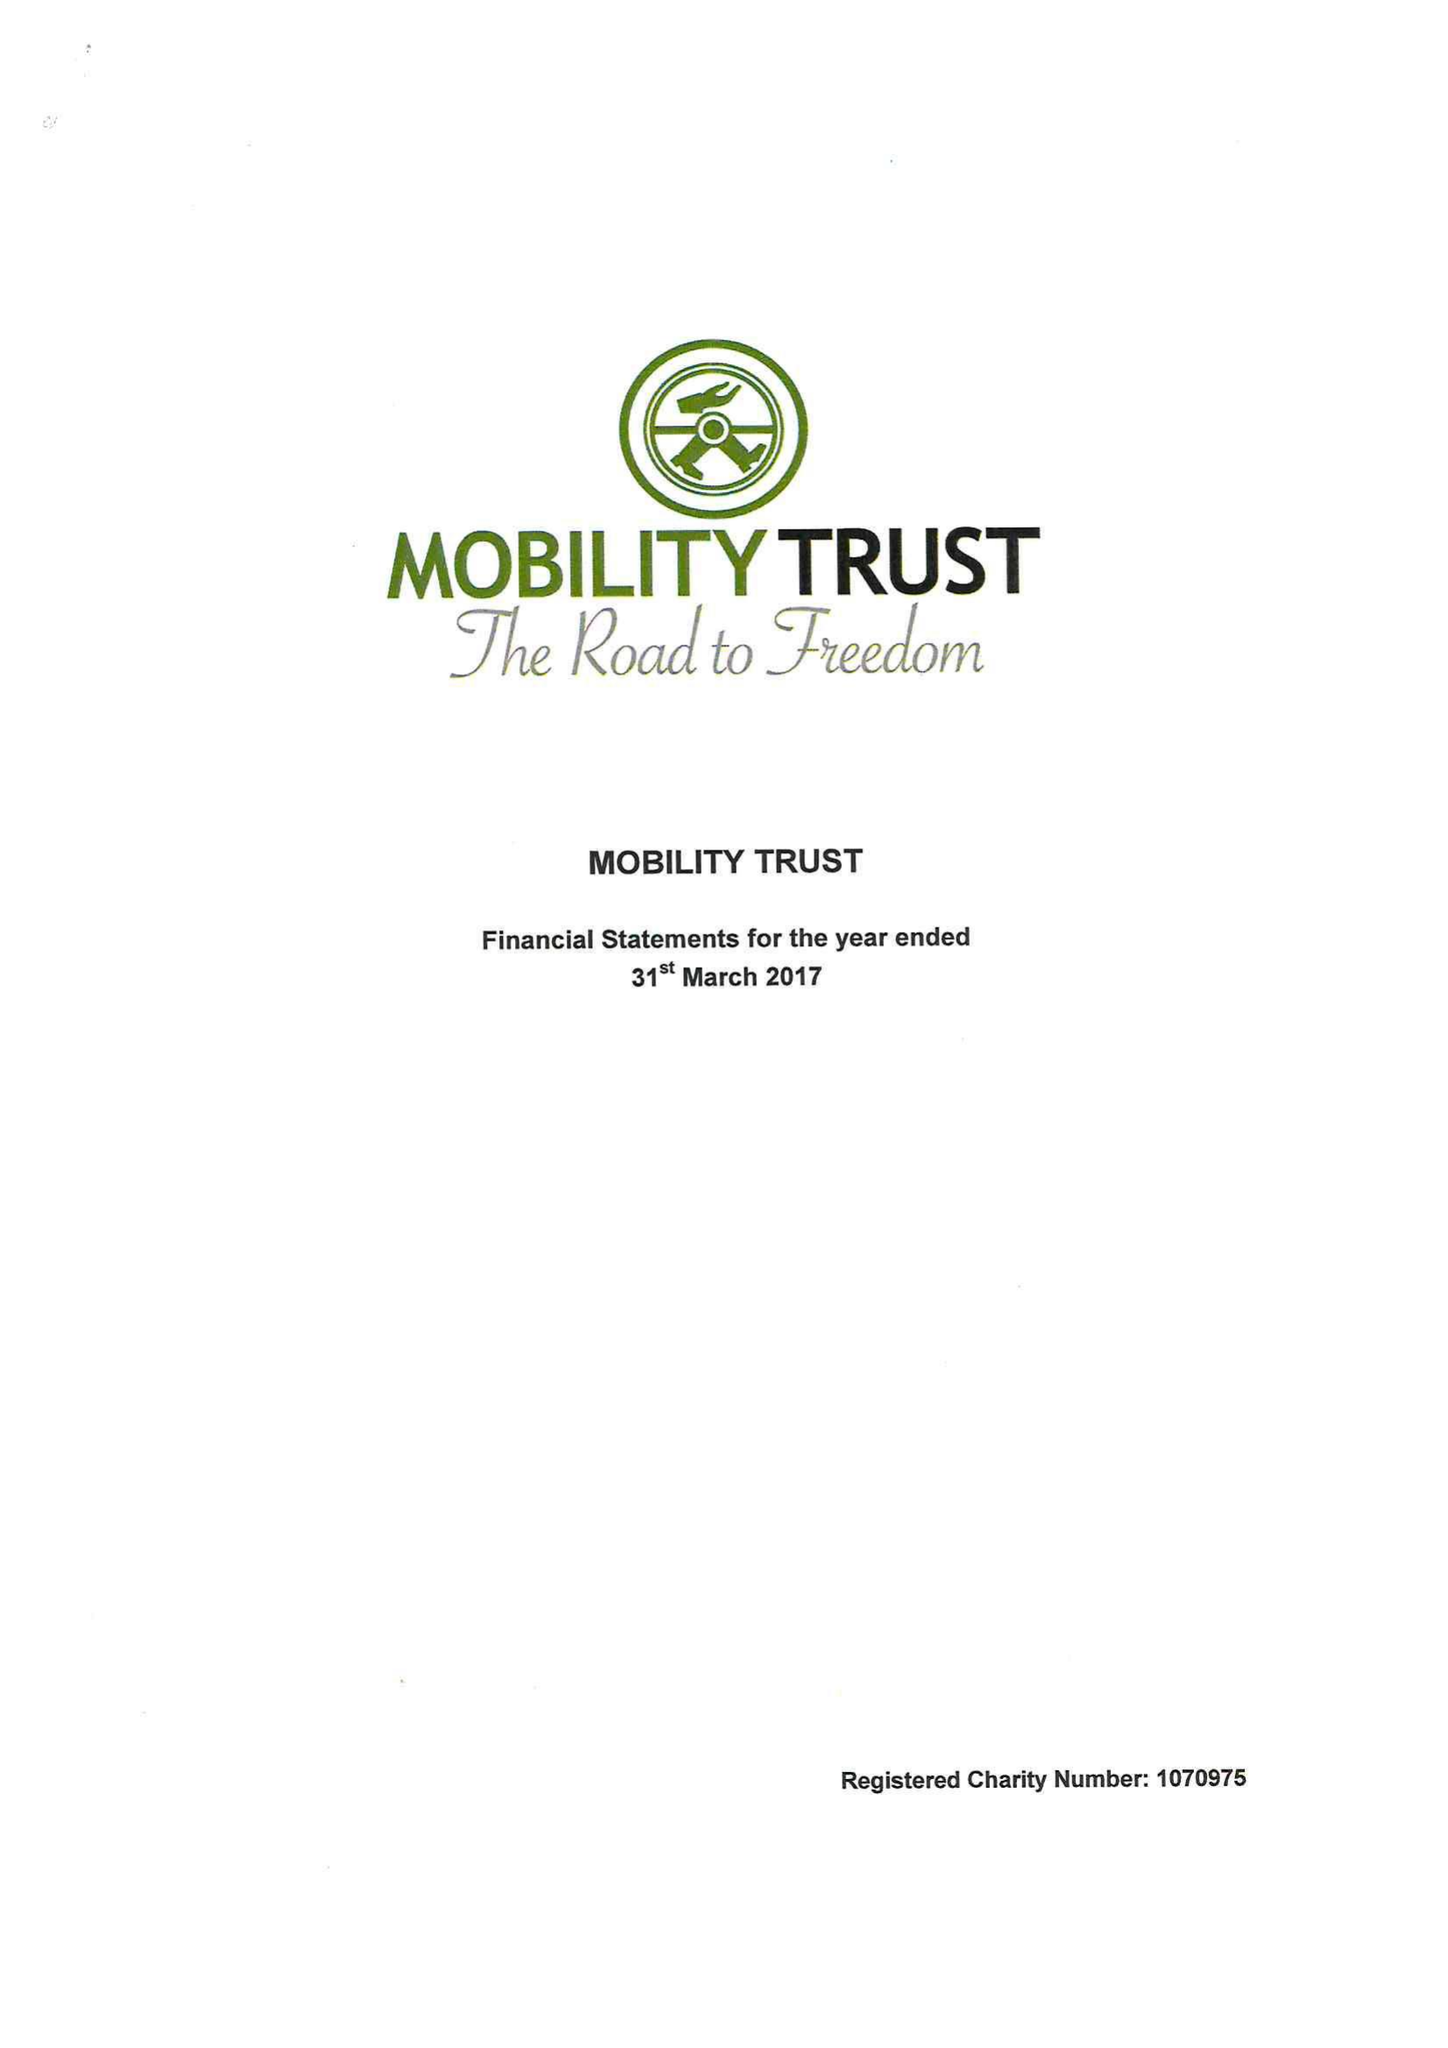What is the value for the income_annually_in_british_pounds?
Answer the question using a single word or phrase. 412758.00 